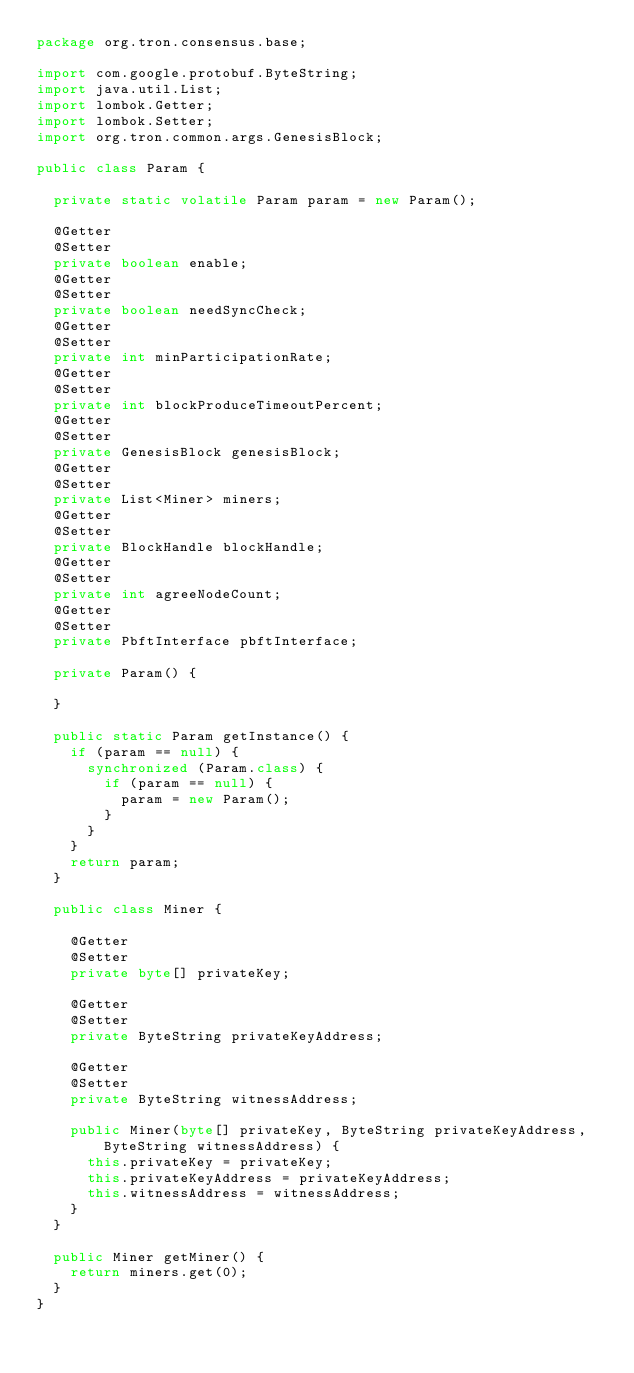<code> <loc_0><loc_0><loc_500><loc_500><_Java_>package org.tron.consensus.base;

import com.google.protobuf.ByteString;
import java.util.List;
import lombok.Getter;
import lombok.Setter;
import org.tron.common.args.GenesisBlock;

public class Param {

  private static volatile Param param = new Param();

  @Getter
  @Setter
  private boolean enable;
  @Getter
  @Setter
  private boolean needSyncCheck;
  @Getter
  @Setter
  private int minParticipationRate;
  @Getter
  @Setter
  private int blockProduceTimeoutPercent;
  @Getter
  @Setter
  private GenesisBlock genesisBlock;
  @Getter
  @Setter
  private List<Miner> miners;
  @Getter
  @Setter
  private BlockHandle blockHandle;
  @Getter
  @Setter
  private int agreeNodeCount;
  @Getter
  @Setter
  private PbftInterface pbftInterface;

  private Param() {

  }

  public static Param getInstance() {
    if (param == null) {
      synchronized (Param.class) {
        if (param == null) {
          param = new Param();
        }
      }
    }
    return param;
  }

  public class Miner {

    @Getter
    @Setter
    private byte[] privateKey;

    @Getter
    @Setter
    private ByteString privateKeyAddress;

    @Getter
    @Setter
    private ByteString witnessAddress;

    public Miner(byte[] privateKey, ByteString privateKeyAddress, ByteString witnessAddress) {
      this.privateKey = privateKey;
      this.privateKeyAddress = privateKeyAddress;
      this.witnessAddress = witnessAddress;
    }
  }

  public Miner getMiner() {
    return miners.get(0);
  }
}</code> 